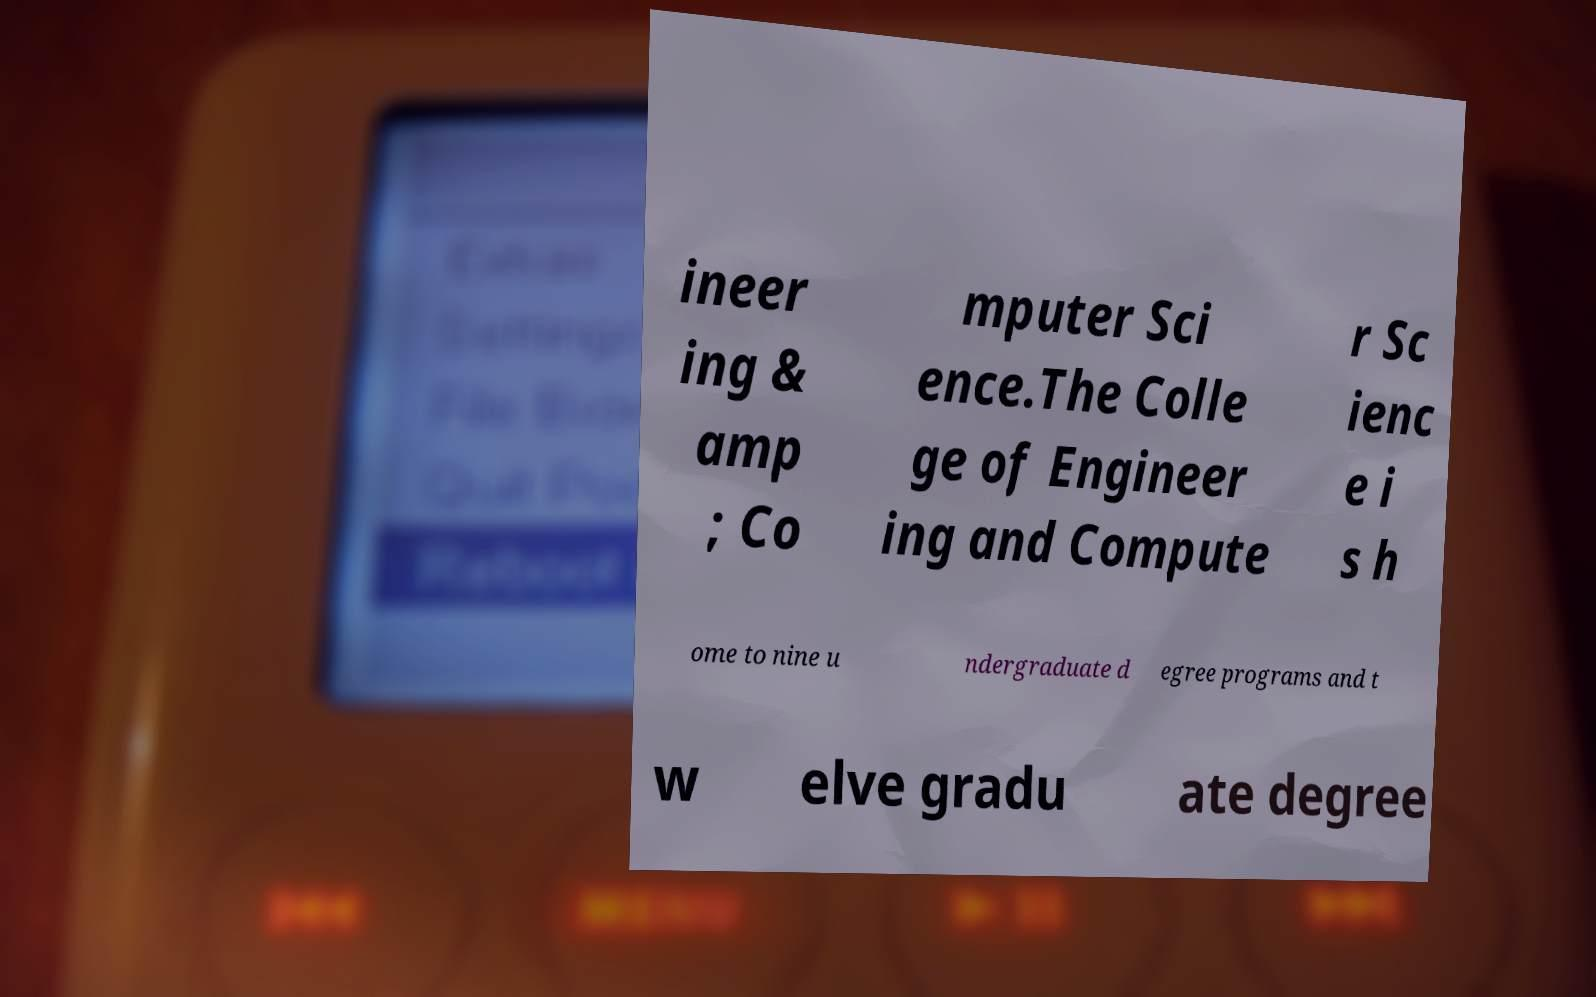I need the written content from this picture converted into text. Can you do that? ineer ing & amp ; Co mputer Sci ence.The Colle ge of Engineer ing and Compute r Sc ienc e i s h ome to nine u ndergraduate d egree programs and t w elve gradu ate degree 